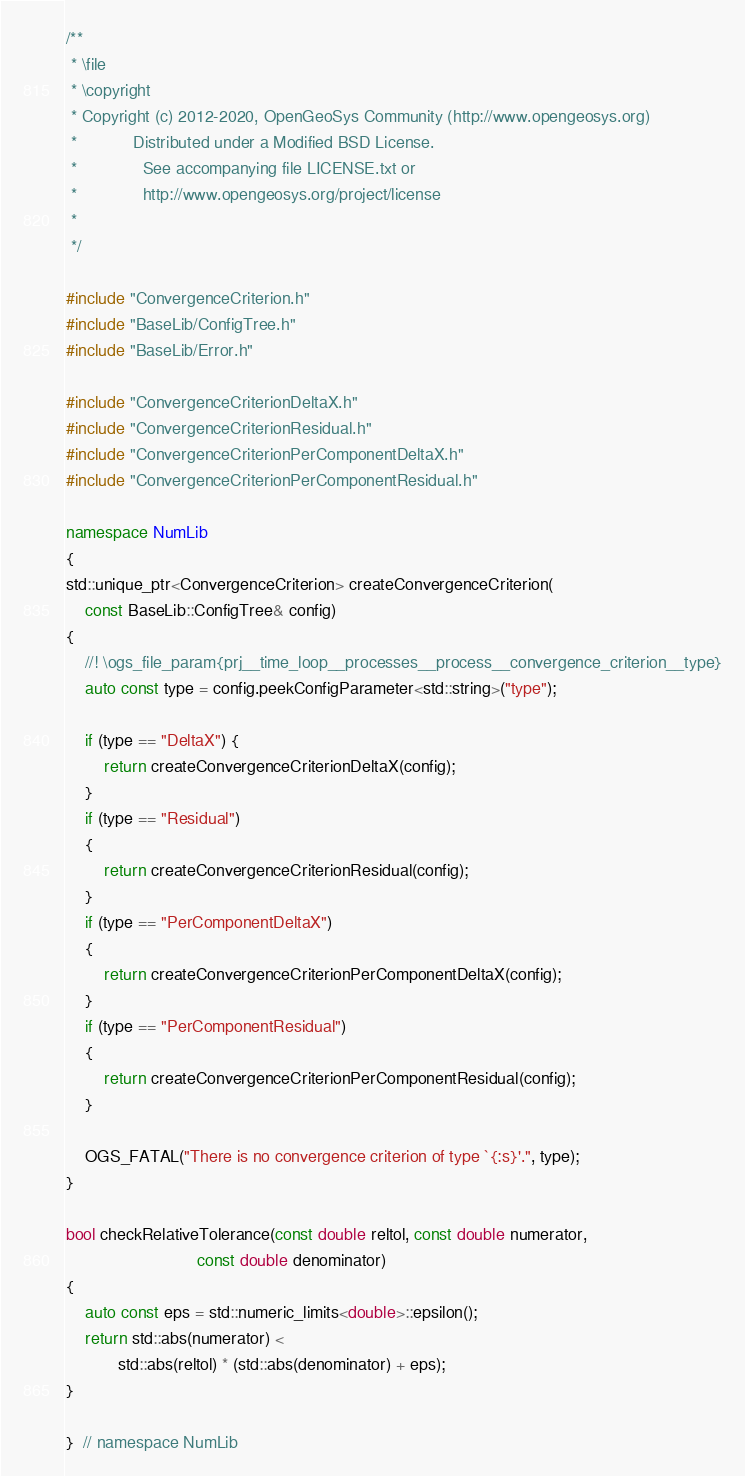Convert code to text. <code><loc_0><loc_0><loc_500><loc_500><_C++_>/**
 * \file
 * \copyright
 * Copyright (c) 2012-2020, OpenGeoSys Community (http://www.opengeosys.org)
 *            Distributed under a Modified BSD License.
 *              See accompanying file LICENSE.txt or
 *              http://www.opengeosys.org/project/license
 *
 */

#include "ConvergenceCriterion.h"
#include "BaseLib/ConfigTree.h"
#include "BaseLib/Error.h"

#include "ConvergenceCriterionDeltaX.h"
#include "ConvergenceCriterionResidual.h"
#include "ConvergenceCriterionPerComponentDeltaX.h"
#include "ConvergenceCriterionPerComponentResidual.h"

namespace NumLib
{
std::unique_ptr<ConvergenceCriterion> createConvergenceCriterion(
    const BaseLib::ConfigTree& config)
{
    //! \ogs_file_param{prj__time_loop__processes__process__convergence_criterion__type}
    auto const type = config.peekConfigParameter<std::string>("type");

    if (type == "DeltaX") {
        return createConvergenceCriterionDeltaX(config);
    }
    if (type == "Residual")
    {
        return createConvergenceCriterionResidual(config);
    }
    if (type == "PerComponentDeltaX")
    {
        return createConvergenceCriterionPerComponentDeltaX(config);
    }
    if (type == "PerComponentResidual")
    {
        return createConvergenceCriterionPerComponentResidual(config);
    }

    OGS_FATAL("There is no convergence criterion of type `{:s}'.", type);
}

bool checkRelativeTolerance(const double reltol, const double numerator,
                            const double denominator)
{
    auto const eps = std::numeric_limits<double>::epsilon();
    return std::abs(numerator) <
           std::abs(reltol) * (std::abs(denominator) + eps);
}

}  // namespace NumLib
</code> 